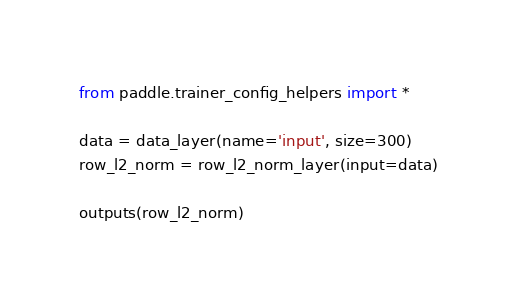<code> <loc_0><loc_0><loc_500><loc_500><_Python_>from paddle.trainer_config_helpers import *

data = data_layer(name='input', size=300)
row_l2_norm = row_l2_norm_layer(input=data)

outputs(row_l2_norm)
</code> 